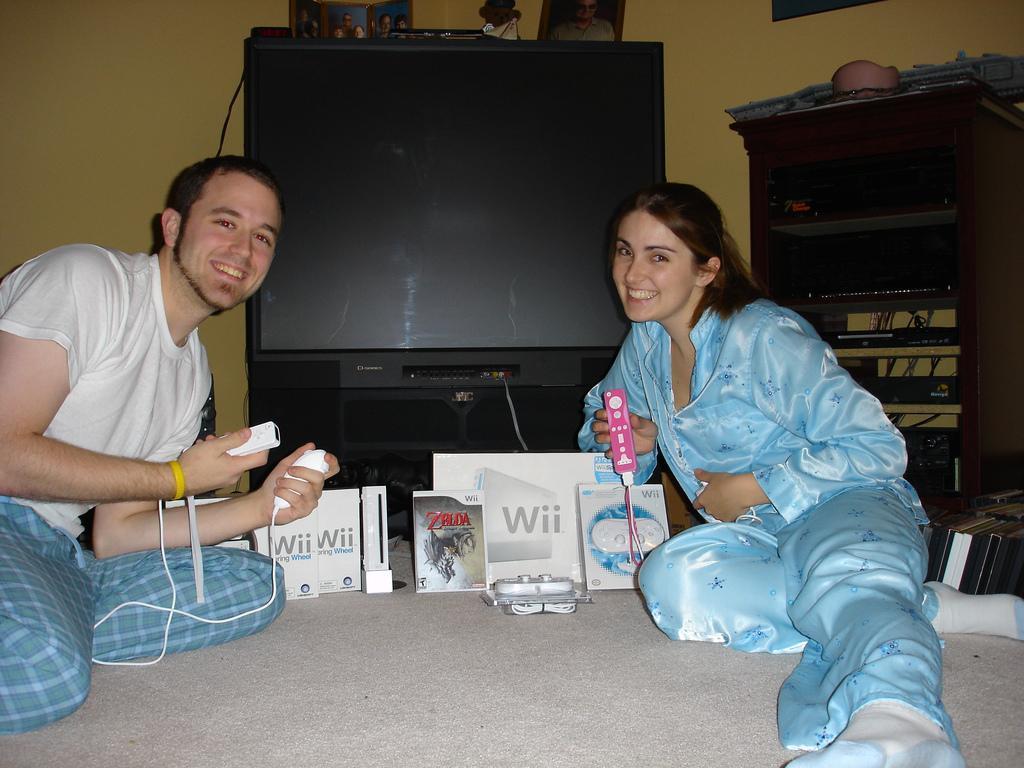How many white wii controller?
Give a very brief answer. 2. How many family photos?
Give a very brief answer. 4. 